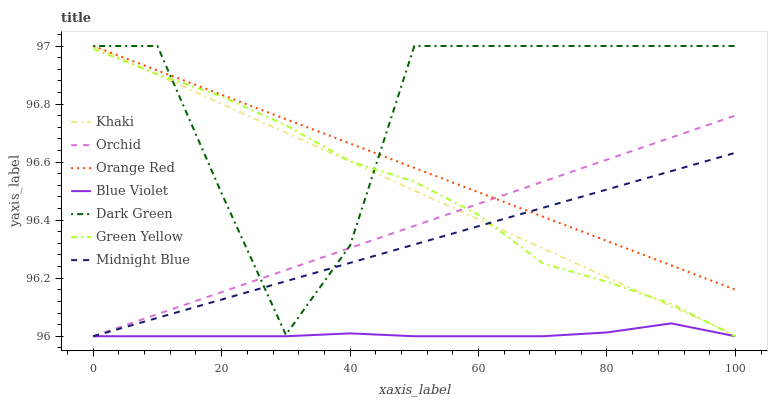Does Blue Violet have the minimum area under the curve?
Answer yes or no. Yes. Does Dark Green have the maximum area under the curve?
Answer yes or no. Yes. Does Khaki have the minimum area under the curve?
Answer yes or no. No. Does Khaki have the maximum area under the curve?
Answer yes or no. No. Is Midnight Blue the smoothest?
Answer yes or no. Yes. Is Dark Green the roughest?
Answer yes or no. Yes. Is Khaki the smoothest?
Answer yes or no. No. Is Khaki the roughest?
Answer yes or no. No. Does Khaki have the lowest value?
Answer yes or no. No. Does Dark Green have the highest value?
Answer yes or no. Yes. Does Midnight Blue have the highest value?
Answer yes or no. No. Is Blue Violet less than Dark Green?
Answer yes or no. Yes. Is Orange Red greater than Blue Violet?
Answer yes or no. Yes. Does Blue Violet intersect Orchid?
Answer yes or no. Yes. Is Blue Violet less than Orchid?
Answer yes or no. No. Is Blue Violet greater than Orchid?
Answer yes or no. No. Does Blue Violet intersect Dark Green?
Answer yes or no. No. 